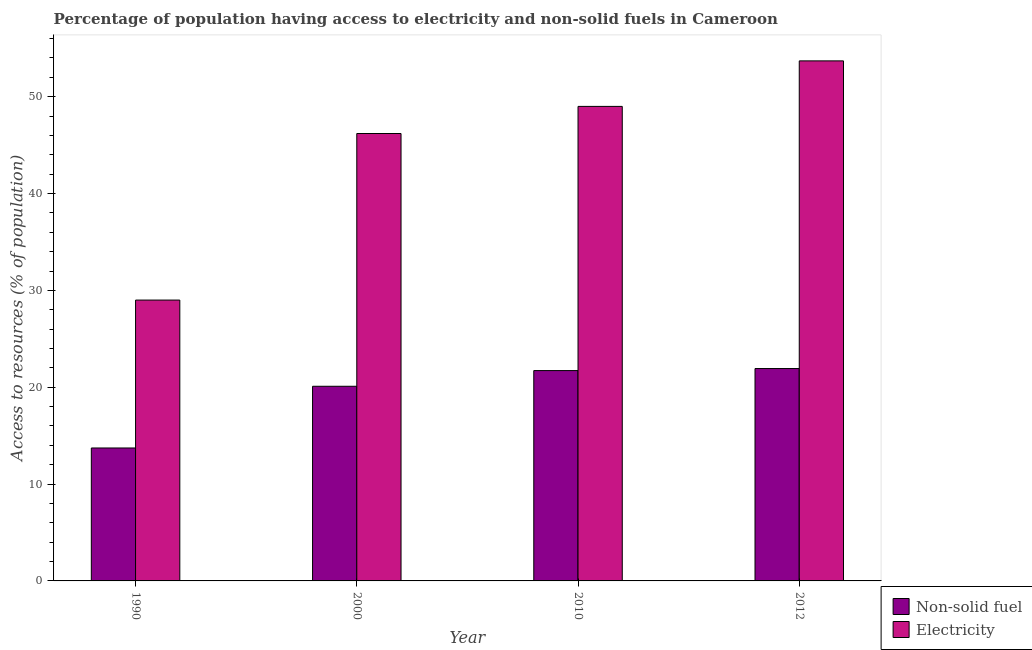How many groups of bars are there?
Offer a terse response. 4. Are the number of bars per tick equal to the number of legend labels?
Your response must be concise. Yes. How many bars are there on the 1st tick from the right?
Offer a terse response. 2. What is the label of the 2nd group of bars from the left?
Make the answer very short. 2000. In how many cases, is the number of bars for a given year not equal to the number of legend labels?
Your response must be concise. 0. What is the percentage of population having access to electricity in 2000?
Provide a short and direct response. 46.2. Across all years, what is the maximum percentage of population having access to non-solid fuel?
Give a very brief answer. 21.93. Across all years, what is the minimum percentage of population having access to non-solid fuel?
Your answer should be compact. 13.73. In which year was the percentage of population having access to non-solid fuel maximum?
Ensure brevity in your answer.  2012. What is the total percentage of population having access to electricity in the graph?
Keep it short and to the point. 177.9. What is the difference between the percentage of population having access to non-solid fuel in 1990 and that in 2000?
Ensure brevity in your answer.  -6.37. What is the difference between the percentage of population having access to electricity in 1990 and the percentage of population having access to non-solid fuel in 2000?
Your answer should be compact. -17.2. What is the average percentage of population having access to electricity per year?
Give a very brief answer. 44.48. In the year 2012, what is the difference between the percentage of population having access to non-solid fuel and percentage of population having access to electricity?
Ensure brevity in your answer.  0. In how many years, is the percentage of population having access to non-solid fuel greater than 28 %?
Make the answer very short. 0. What is the ratio of the percentage of population having access to non-solid fuel in 1990 to that in 2000?
Ensure brevity in your answer.  0.68. Is the difference between the percentage of population having access to non-solid fuel in 2000 and 2012 greater than the difference between the percentage of population having access to electricity in 2000 and 2012?
Provide a succinct answer. No. What is the difference between the highest and the second highest percentage of population having access to electricity?
Make the answer very short. 4.7. What is the difference between the highest and the lowest percentage of population having access to non-solid fuel?
Offer a very short reply. 8.2. Is the sum of the percentage of population having access to electricity in 1990 and 2000 greater than the maximum percentage of population having access to non-solid fuel across all years?
Offer a very short reply. Yes. What does the 1st bar from the left in 2010 represents?
Provide a short and direct response. Non-solid fuel. What does the 2nd bar from the right in 2012 represents?
Your answer should be very brief. Non-solid fuel. How many bars are there?
Offer a terse response. 8. How many years are there in the graph?
Make the answer very short. 4. Does the graph contain any zero values?
Keep it short and to the point. No. How are the legend labels stacked?
Your answer should be compact. Vertical. What is the title of the graph?
Ensure brevity in your answer.  Percentage of population having access to electricity and non-solid fuels in Cameroon. What is the label or title of the Y-axis?
Provide a succinct answer. Access to resources (% of population). What is the Access to resources (% of population) in Non-solid fuel in 1990?
Make the answer very short. 13.73. What is the Access to resources (% of population) in Electricity in 1990?
Make the answer very short. 29. What is the Access to resources (% of population) of Non-solid fuel in 2000?
Make the answer very short. 20.1. What is the Access to resources (% of population) of Electricity in 2000?
Ensure brevity in your answer.  46.2. What is the Access to resources (% of population) of Non-solid fuel in 2010?
Provide a succinct answer. 21.72. What is the Access to resources (% of population) of Electricity in 2010?
Your answer should be very brief. 49. What is the Access to resources (% of population) in Non-solid fuel in 2012?
Offer a very short reply. 21.93. What is the Access to resources (% of population) of Electricity in 2012?
Make the answer very short. 53.7. Across all years, what is the maximum Access to resources (% of population) of Non-solid fuel?
Keep it short and to the point. 21.93. Across all years, what is the maximum Access to resources (% of population) in Electricity?
Provide a succinct answer. 53.7. Across all years, what is the minimum Access to resources (% of population) of Non-solid fuel?
Give a very brief answer. 13.73. What is the total Access to resources (% of population) of Non-solid fuel in the graph?
Give a very brief answer. 77.48. What is the total Access to resources (% of population) of Electricity in the graph?
Offer a very short reply. 177.9. What is the difference between the Access to resources (% of population) of Non-solid fuel in 1990 and that in 2000?
Ensure brevity in your answer.  -6.37. What is the difference between the Access to resources (% of population) of Electricity in 1990 and that in 2000?
Your answer should be compact. -17.2. What is the difference between the Access to resources (% of population) of Non-solid fuel in 1990 and that in 2010?
Offer a very short reply. -7.99. What is the difference between the Access to resources (% of population) of Electricity in 1990 and that in 2010?
Provide a succinct answer. -20. What is the difference between the Access to resources (% of population) in Non-solid fuel in 1990 and that in 2012?
Offer a terse response. -8.2. What is the difference between the Access to resources (% of population) in Electricity in 1990 and that in 2012?
Ensure brevity in your answer.  -24.7. What is the difference between the Access to resources (% of population) in Non-solid fuel in 2000 and that in 2010?
Keep it short and to the point. -1.62. What is the difference between the Access to resources (% of population) of Electricity in 2000 and that in 2010?
Provide a succinct answer. -2.8. What is the difference between the Access to resources (% of population) in Non-solid fuel in 2000 and that in 2012?
Offer a terse response. -1.83. What is the difference between the Access to resources (% of population) in Non-solid fuel in 2010 and that in 2012?
Provide a short and direct response. -0.21. What is the difference between the Access to resources (% of population) in Electricity in 2010 and that in 2012?
Your response must be concise. -4.7. What is the difference between the Access to resources (% of population) in Non-solid fuel in 1990 and the Access to resources (% of population) in Electricity in 2000?
Offer a very short reply. -32.47. What is the difference between the Access to resources (% of population) of Non-solid fuel in 1990 and the Access to resources (% of population) of Electricity in 2010?
Give a very brief answer. -35.27. What is the difference between the Access to resources (% of population) in Non-solid fuel in 1990 and the Access to resources (% of population) in Electricity in 2012?
Your response must be concise. -39.97. What is the difference between the Access to resources (% of population) of Non-solid fuel in 2000 and the Access to resources (% of population) of Electricity in 2010?
Provide a succinct answer. -28.9. What is the difference between the Access to resources (% of population) in Non-solid fuel in 2000 and the Access to resources (% of population) in Electricity in 2012?
Give a very brief answer. -33.6. What is the difference between the Access to resources (% of population) in Non-solid fuel in 2010 and the Access to resources (% of population) in Electricity in 2012?
Make the answer very short. -31.98. What is the average Access to resources (% of population) of Non-solid fuel per year?
Your answer should be compact. 19.37. What is the average Access to resources (% of population) in Electricity per year?
Provide a short and direct response. 44.48. In the year 1990, what is the difference between the Access to resources (% of population) of Non-solid fuel and Access to resources (% of population) of Electricity?
Provide a succinct answer. -15.27. In the year 2000, what is the difference between the Access to resources (% of population) of Non-solid fuel and Access to resources (% of population) of Electricity?
Provide a short and direct response. -26.1. In the year 2010, what is the difference between the Access to resources (% of population) of Non-solid fuel and Access to resources (% of population) of Electricity?
Your answer should be very brief. -27.28. In the year 2012, what is the difference between the Access to resources (% of population) in Non-solid fuel and Access to resources (% of population) in Electricity?
Offer a terse response. -31.77. What is the ratio of the Access to resources (% of population) in Non-solid fuel in 1990 to that in 2000?
Ensure brevity in your answer.  0.68. What is the ratio of the Access to resources (% of population) in Electricity in 1990 to that in 2000?
Your response must be concise. 0.63. What is the ratio of the Access to resources (% of population) in Non-solid fuel in 1990 to that in 2010?
Your response must be concise. 0.63. What is the ratio of the Access to resources (% of population) in Electricity in 1990 to that in 2010?
Your response must be concise. 0.59. What is the ratio of the Access to resources (% of population) in Non-solid fuel in 1990 to that in 2012?
Provide a succinct answer. 0.63. What is the ratio of the Access to resources (% of population) of Electricity in 1990 to that in 2012?
Your answer should be compact. 0.54. What is the ratio of the Access to resources (% of population) of Non-solid fuel in 2000 to that in 2010?
Offer a terse response. 0.93. What is the ratio of the Access to resources (% of population) of Electricity in 2000 to that in 2010?
Offer a terse response. 0.94. What is the ratio of the Access to resources (% of population) of Non-solid fuel in 2000 to that in 2012?
Offer a very short reply. 0.92. What is the ratio of the Access to resources (% of population) in Electricity in 2000 to that in 2012?
Offer a terse response. 0.86. What is the ratio of the Access to resources (% of population) of Non-solid fuel in 2010 to that in 2012?
Give a very brief answer. 0.99. What is the ratio of the Access to resources (% of population) of Electricity in 2010 to that in 2012?
Your answer should be very brief. 0.91. What is the difference between the highest and the second highest Access to resources (% of population) of Non-solid fuel?
Offer a very short reply. 0.21. What is the difference between the highest and the second highest Access to resources (% of population) in Electricity?
Give a very brief answer. 4.7. What is the difference between the highest and the lowest Access to resources (% of population) in Non-solid fuel?
Give a very brief answer. 8.2. What is the difference between the highest and the lowest Access to resources (% of population) in Electricity?
Your response must be concise. 24.7. 